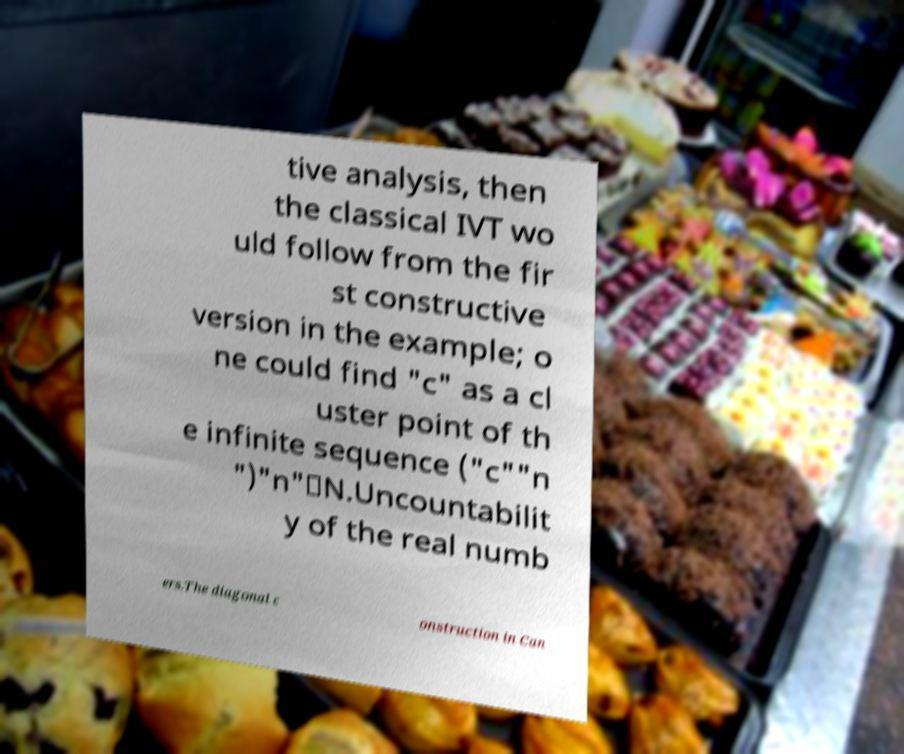Can you read and provide the text displayed in the image?This photo seems to have some interesting text. Can you extract and type it out for me? tive analysis, then the classical IVT wo uld follow from the fir st constructive version in the example; o ne could find "c" as a cl uster point of th e infinite sequence ("c""n ")"n"∈N.Uncountabilit y of the real numb ers.The diagonal c onstruction in Can 